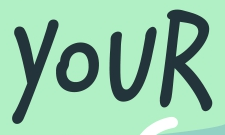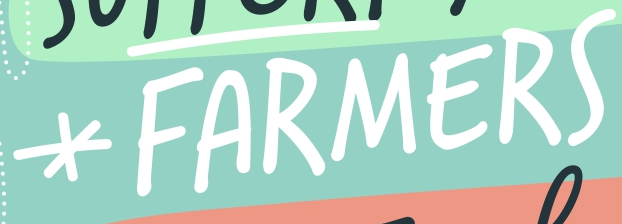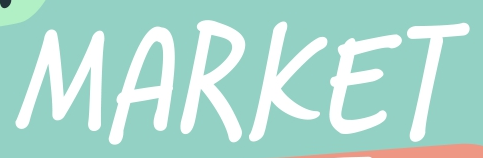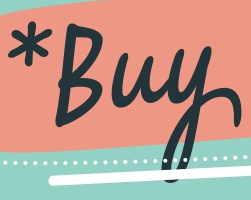What text appears in these images from left to right, separated by a semicolon? YOUR; *FARMERS; MARKET; *Buy 